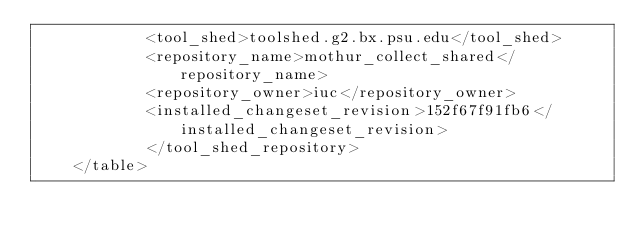<code> <loc_0><loc_0><loc_500><loc_500><_XML_>            <tool_shed>toolshed.g2.bx.psu.edu</tool_shed>
            <repository_name>mothur_collect_shared</repository_name>
            <repository_owner>iuc</repository_owner>
            <installed_changeset_revision>152f67f91fb6</installed_changeset_revision>
            </tool_shed_repository>
    </table></code> 